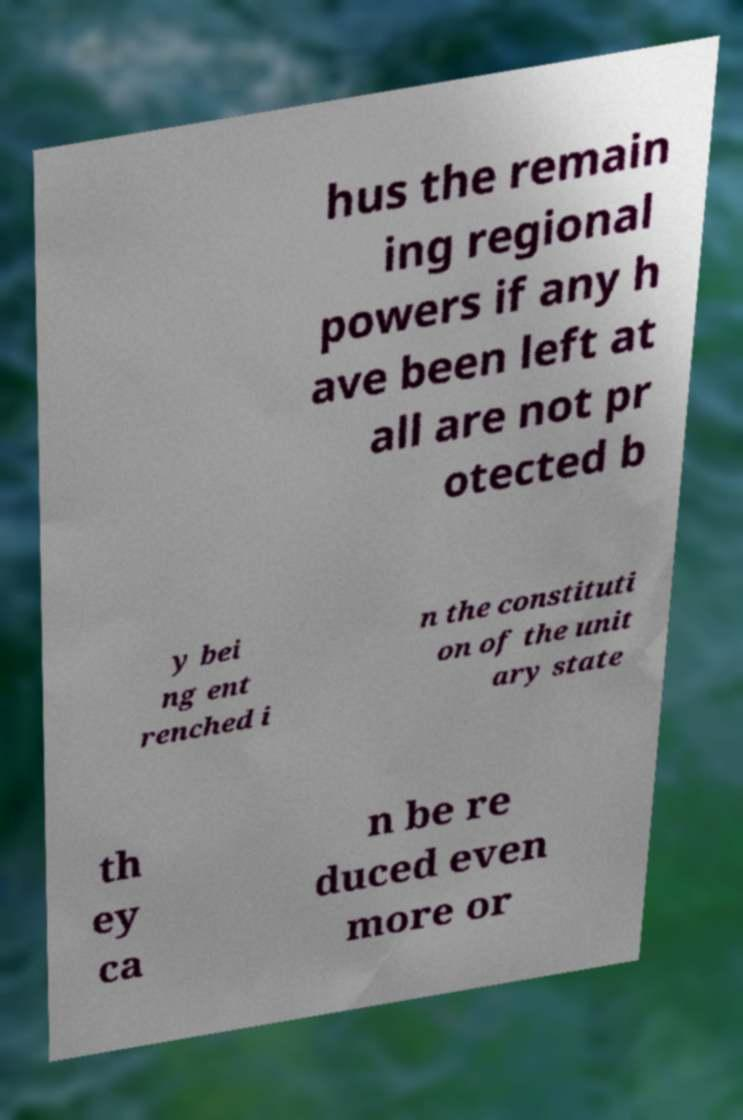Can you accurately transcribe the text from the provided image for me? hus the remain ing regional powers if any h ave been left at all are not pr otected b y bei ng ent renched i n the constituti on of the unit ary state th ey ca n be re duced even more or 